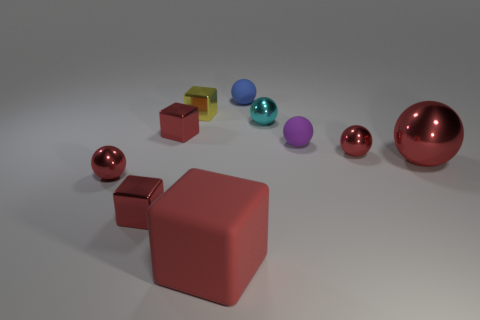Subtract all yellow cylinders. How many red spheres are left? 3 Subtract all purple balls. How many balls are left? 5 Subtract 3 balls. How many balls are left? 3 Subtract all tiny purple matte balls. How many balls are left? 5 Subtract all blue spheres. Subtract all blue cubes. How many spheres are left? 5 Subtract all cubes. How many objects are left? 6 Add 1 red metallic spheres. How many red metallic spheres are left? 4 Add 6 gray rubber cubes. How many gray rubber cubes exist? 6 Subtract 0 yellow cylinders. How many objects are left? 10 Subtract all red metallic spheres. Subtract all small red objects. How many objects are left? 3 